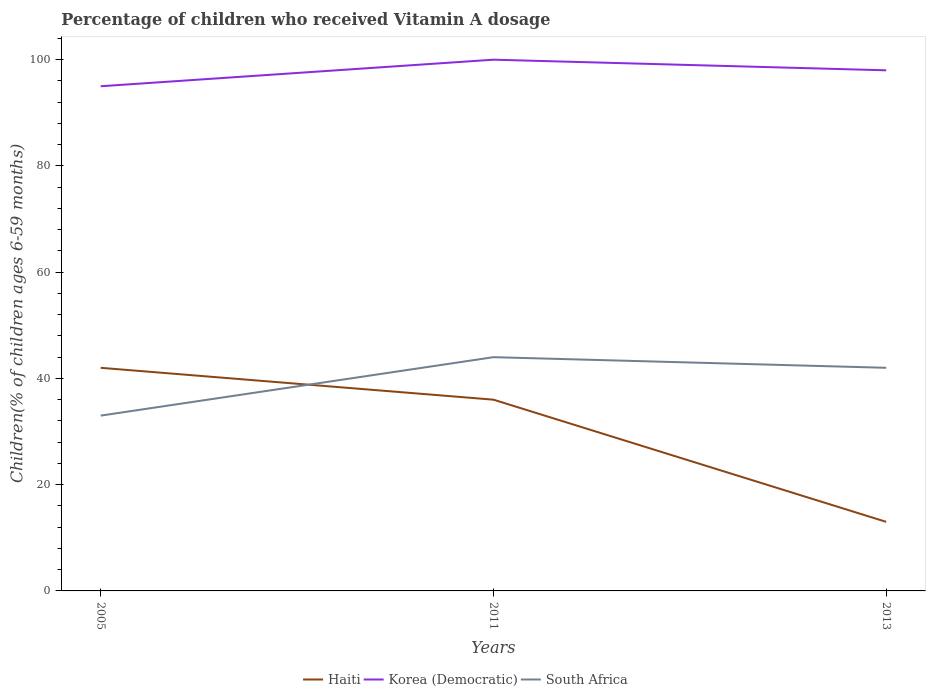What is the difference between the highest and the second highest percentage of children who received Vitamin A dosage in South Africa?
Offer a very short reply. 11. Is the percentage of children who received Vitamin A dosage in Korea (Democratic) strictly greater than the percentage of children who received Vitamin A dosage in South Africa over the years?
Provide a succinct answer. No. How many years are there in the graph?
Give a very brief answer. 3. Does the graph contain any zero values?
Your answer should be very brief. No. Does the graph contain grids?
Make the answer very short. No. Where does the legend appear in the graph?
Your answer should be very brief. Bottom center. How many legend labels are there?
Provide a succinct answer. 3. How are the legend labels stacked?
Your answer should be compact. Horizontal. What is the title of the graph?
Make the answer very short. Percentage of children who received Vitamin A dosage. Does "Bangladesh" appear as one of the legend labels in the graph?
Give a very brief answer. No. What is the label or title of the X-axis?
Give a very brief answer. Years. What is the label or title of the Y-axis?
Your answer should be very brief. Children(% of children ages 6-59 months). What is the Children(% of children ages 6-59 months) in Haiti in 2005?
Provide a succinct answer. 42. What is the Children(% of children ages 6-59 months) in South Africa in 2005?
Offer a terse response. 33. What is the Children(% of children ages 6-59 months) of South Africa in 2011?
Your answer should be very brief. 44. What is the total Children(% of children ages 6-59 months) of Haiti in the graph?
Make the answer very short. 91. What is the total Children(% of children ages 6-59 months) of Korea (Democratic) in the graph?
Give a very brief answer. 293. What is the total Children(% of children ages 6-59 months) of South Africa in the graph?
Your answer should be very brief. 119. What is the difference between the Children(% of children ages 6-59 months) in South Africa in 2005 and that in 2011?
Provide a short and direct response. -11. What is the difference between the Children(% of children ages 6-59 months) in Haiti in 2005 and that in 2013?
Your answer should be very brief. 29. What is the difference between the Children(% of children ages 6-59 months) in South Africa in 2005 and that in 2013?
Give a very brief answer. -9. What is the difference between the Children(% of children ages 6-59 months) of Haiti in 2011 and that in 2013?
Your answer should be compact. 23. What is the difference between the Children(% of children ages 6-59 months) of South Africa in 2011 and that in 2013?
Your response must be concise. 2. What is the difference between the Children(% of children ages 6-59 months) of Haiti in 2005 and the Children(% of children ages 6-59 months) of Korea (Democratic) in 2011?
Ensure brevity in your answer.  -58. What is the difference between the Children(% of children ages 6-59 months) in Korea (Democratic) in 2005 and the Children(% of children ages 6-59 months) in South Africa in 2011?
Give a very brief answer. 51. What is the difference between the Children(% of children ages 6-59 months) of Haiti in 2005 and the Children(% of children ages 6-59 months) of Korea (Democratic) in 2013?
Offer a very short reply. -56. What is the difference between the Children(% of children ages 6-59 months) in Haiti in 2005 and the Children(% of children ages 6-59 months) in South Africa in 2013?
Offer a terse response. 0. What is the difference between the Children(% of children ages 6-59 months) in Haiti in 2011 and the Children(% of children ages 6-59 months) in Korea (Democratic) in 2013?
Provide a succinct answer. -62. What is the average Children(% of children ages 6-59 months) in Haiti per year?
Your response must be concise. 30.33. What is the average Children(% of children ages 6-59 months) of Korea (Democratic) per year?
Keep it short and to the point. 97.67. What is the average Children(% of children ages 6-59 months) in South Africa per year?
Your response must be concise. 39.67. In the year 2005, what is the difference between the Children(% of children ages 6-59 months) in Haiti and Children(% of children ages 6-59 months) in Korea (Democratic)?
Provide a short and direct response. -53. In the year 2011, what is the difference between the Children(% of children ages 6-59 months) in Haiti and Children(% of children ages 6-59 months) in Korea (Democratic)?
Your answer should be compact. -64. In the year 2011, what is the difference between the Children(% of children ages 6-59 months) in Korea (Democratic) and Children(% of children ages 6-59 months) in South Africa?
Your answer should be compact. 56. In the year 2013, what is the difference between the Children(% of children ages 6-59 months) of Haiti and Children(% of children ages 6-59 months) of Korea (Democratic)?
Keep it short and to the point. -85. In the year 2013, what is the difference between the Children(% of children ages 6-59 months) in Haiti and Children(% of children ages 6-59 months) in South Africa?
Provide a short and direct response. -29. What is the ratio of the Children(% of children ages 6-59 months) of Haiti in 2005 to that in 2011?
Your answer should be compact. 1.17. What is the ratio of the Children(% of children ages 6-59 months) of Korea (Democratic) in 2005 to that in 2011?
Make the answer very short. 0.95. What is the ratio of the Children(% of children ages 6-59 months) in Haiti in 2005 to that in 2013?
Ensure brevity in your answer.  3.23. What is the ratio of the Children(% of children ages 6-59 months) in Korea (Democratic) in 2005 to that in 2013?
Make the answer very short. 0.97. What is the ratio of the Children(% of children ages 6-59 months) in South Africa in 2005 to that in 2013?
Offer a very short reply. 0.79. What is the ratio of the Children(% of children ages 6-59 months) in Haiti in 2011 to that in 2013?
Offer a terse response. 2.77. What is the ratio of the Children(% of children ages 6-59 months) of Korea (Democratic) in 2011 to that in 2013?
Offer a terse response. 1.02. What is the ratio of the Children(% of children ages 6-59 months) of South Africa in 2011 to that in 2013?
Make the answer very short. 1.05. What is the difference between the highest and the second highest Children(% of children ages 6-59 months) in Korea (Democratic)?
Make the answer very short. 2. What is the difference between the highest and the lowest Children(% of children ages 6-59 months) in Korea (Democratic)?
Provide a short and direct response. 5. 